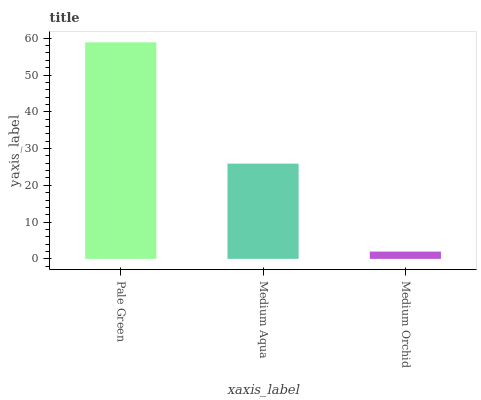Is Medium Orchid the minimum?
Answer yes or no. Yes. Is Pale Green the maximum?
Answer yes or no. Yes. Is Medium Aqua the minimum?
Answer yes or no. No. Is Medium Aqua the maximum?
Answer yes or no. No. Is Pale Green greater than Medium Aqua?
Answer yes or no. Yes. Is Medium Aqua less than Pale Green?
Answer yes or no. Yes. Is Medium Aqua greater than Pale Green?
Answer yes or no. No. Is Pale Green less than Medium Aqua?
Answer yes or no. No. Is Medium Aqua the high median?
Answer yes or no. Yes. Is Medium Aqua the low median?
Answer yes or no. Yes. Is Pale Green the high median?
Answer yes or no. No. Is Medium Orchid the low median?
Answer yes or no. No. 